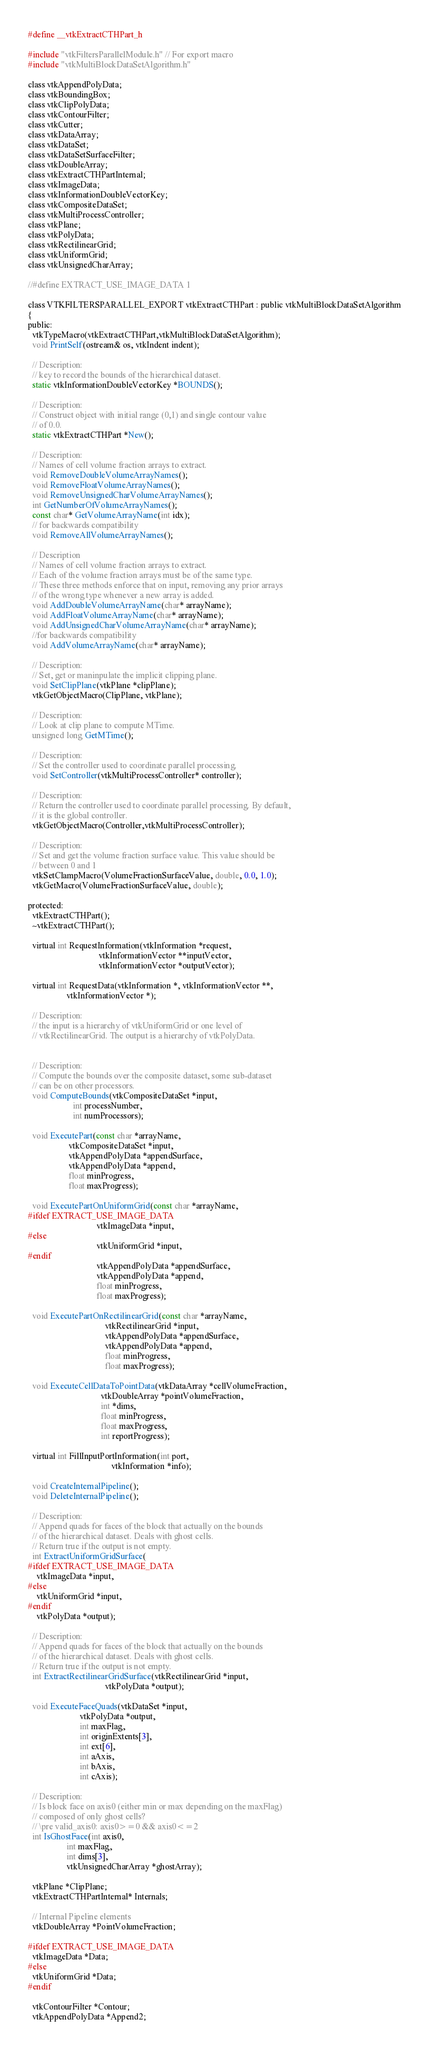Convert code to text. <code><loc_0><loc_0><loc_500><loc_500><_C_>#define __vtkExtractCTHPart_h

#include "vtkFiltersParallelModule.h" // For export macro
#include "vtkMultiBlockDataSetAlgorithm.h"

class vtkAppendPolyData;
class vtkBoundingBox;
class vtkClipPolyData;
class vtkContourFilter;
class vtkCutter;
class vtkDataArray;
class vtkDataSet;
class vtkDataSetSurfaceFilter;
class vtkDoubleArray;
class vtkExtractCTHPartInternal;
class vtkImageData;
class vtkInformationDoubleVectorKey;
class vtkCompositeDataSet;
class vtkMultiProcessController;
class vtkPlane;
class vtkPolyData;
class vtkRectilinearGrid;
class vtkUniformGrid;
class vtkUnsignedCharArray;

//#define EXTRACT_USE_IMAGE_DATA 1

class VTKFILTERSPARALLEL_EXPORT vtkExtractCTHPart : public vtkMultiBlockDataSetAlgorithm
{
public:
  vtkTypeMacro(vtkExtractCTHPart,vtkMultiBlockDataSetAlgorithm);
  void PrintSelf(ostream& os, vtkIndent indent);

  // Description:
  // key to record the bounds of the hierarchical dataset.
  static vtkInformationDoubleVectorKey *BOUNDS();

  // Description:
  // Construct object with initial range (0,1) and single contour value
  // of 0.0.
  static vtkExtractCTHPart *New();

  // Description:
  // Names of cell volume fraction arrays to extract.
  void RemoveDoubleVolumeArrayNames();
  void RemoveFloatVolumeArrayNames();
  void RemoveUnsignedCharVolumeArrayNames();
  int GetNumberOfVolumeArrayNames();
  const char* GetVolumeArrayName(int idx);
  // for backwards compatibility
  void RemoveAllVolumeArrayNames();

  // Description
  // Names of cell volume fraction arrays to extract.
  // Each of the volume fraction arrays must be of the same type.
  // These three methods enforce that on input, removing any prior arrays
  // of the wrong type whenever a new array is added.
  void AddDoubleVolumeArrayName(char* arrayName);
  void AddFloatVolumeArrayName(char* arrayName);
  void AddUnsignedCharVolumeArrayName(char* arrayName);
  //for backwards compatibility
  void AddVolumeArrayName(char* arrayName);

  // Description:
  // Set, get or maninpulate the implicit clipping plane.
  void SetClipPlane(vtkPlane *clipPlane);
  vtkGetObjectMacro(ClipPlane, vtkPlane);

  // Description:
  // Look at clip plane to compute MTime.
  unsigned long GetMTime();

  // Description:
  // Set the controller used to coordinate parallel processing.
  void SetController(vtkMultiProcessController* controller);

  // Description:
  // Return the controller used to coordinate parallel processing. By default,
  // it is the global controller.
  vtkGetObjectMacro(Controller,vtkMultiProcessController);

  // Description:
  // Set and get the volume fraction surface value. This value should be
  // between 0 and 1
  vtkSetClampMacro(VolumeFractionSurfaceValue, double, 0.0, 1.0);
  vtkGetMacro(VolumeFractionSurfaceValue, double);

protected:
  vtkExtractCTHPart();
  ~vtkExtractCTHPart();

  virtual int RequestInformation(vtkInformation *request,
                                 vtkInformationVector **inputVector,
                                 vtkInformationVector *outputVector);

  virtual int RequestData(vtkInformation *, vtkInformationVector **,
                  vtkInformationVector *);

  // Description:
  // the input is a hierarchy of vtkUniformGrid or one level of
  // vtkRectilinearGrid. The output is a hierarchy of vtkPolyData.


  // Description:
  // Compute the bounds over the composite dataset, some sub-dataset
  // can be on other processors.
  void ComputeBounds(vtkCompositeDataSet *input,
                     int processNumber,
                     int numProcessors);

  void ExecutePart(const char *arrayName,
                   vtkCompositeDataSet *input,
                   vtkAppendPolyData *appendSurface,
                   vtkAppendPolyData *append,
                   float minProgress,
                   float maxProgress);

  void ExecutePartOnUniformGrid(const char *arrayName,
#ifdef EXTRACT_USE_IMAGE_DATA
                                vtkImageData *input,
#else
                                vtkUniformGrid *input,
#endif
                                vtkAppendPolyData *appendSurface,
                                vtkAppendPolyData *append,
                                float minProgress,
                                float maxProgress);

  void ExecutePartOnRectilinearGrid(const char *arrayName,
                                    vtkRectilinearGrid *input,
                                    vtkAppendPolyData *appendSurface,
                                    vtkAppendPolyData *append,
                                    float minProgress,
                                    float maxProgress);

  void ExecuteCellDataToPointData(vtkDataArray *cellVolumeFraction,
                                  vtkDoubleArray *pointVolumeFraction,
                                  int *dims,
                                  float minProgress,
                                  float maxProgress,
                                  int reportProgress);

  virtual int FillInputPortInformation(int port,
                                       vtkInformation *info);

  void CreateInternalPipeline();
  void DeleteInternalPipeline();

  // Description:
  // Append quads for faces of the block that actually on the bounds
  // of the hierarchical dataset. Deals with ghost cells.
  // Return true if the output is not empty.
  int ExtractUniformGridSurface(
#ifdef EXTRACT_USE_IMAGE_DATA
    vtkImageData *input,
#else
    vtkUniformGrid *input,
#endif
    vtkPolyData *output);

  // Description:
  // Append quads for faces of the block that actually on the bounds
  // of the hierarchical dataset. Deals with ghost cells.
  // Return true if the output is not empty.
  int ExtractRectilinearGridSurface(vtkRectilinearGrid *input,
                                    vtkPolyData *output);

  void ExecuteFaceQuads(vtkDataSet *input,
                        vtkPolyData *output,
                        int maxFlag,
                        int originExtents[3],
                        int ext[6],
                        int aAxis,
                        int bAxis,
                        int cAxis);

  // Description:
  // Is block face on axis0 (either min or max depending on the maxFlag)
  // composed of only ghost cells?
  // \pre valid_axis0: axis0>=0 && axis0<=2
  int IsGhostFace(int axis0,
                  int maxFlag,
                  int dims[3],
                  vtkUnsignedCharArray *ghostArray);

  vtkPlane *ClipPlane;
  vtkExtractCTHPartInternal* Internals;

  // Internal Pipeline elements
  vtkDoubleArray *PointVolumeFraction;

#ifdef EXTRACT_USE_IMAGE_DATA
  vtkImageData *Data;
#else
  vtkUniformGrid *Data;
#endif

  vtkContourFilter *Contour;
  vtkAppendPolyData *Append2;</code> 